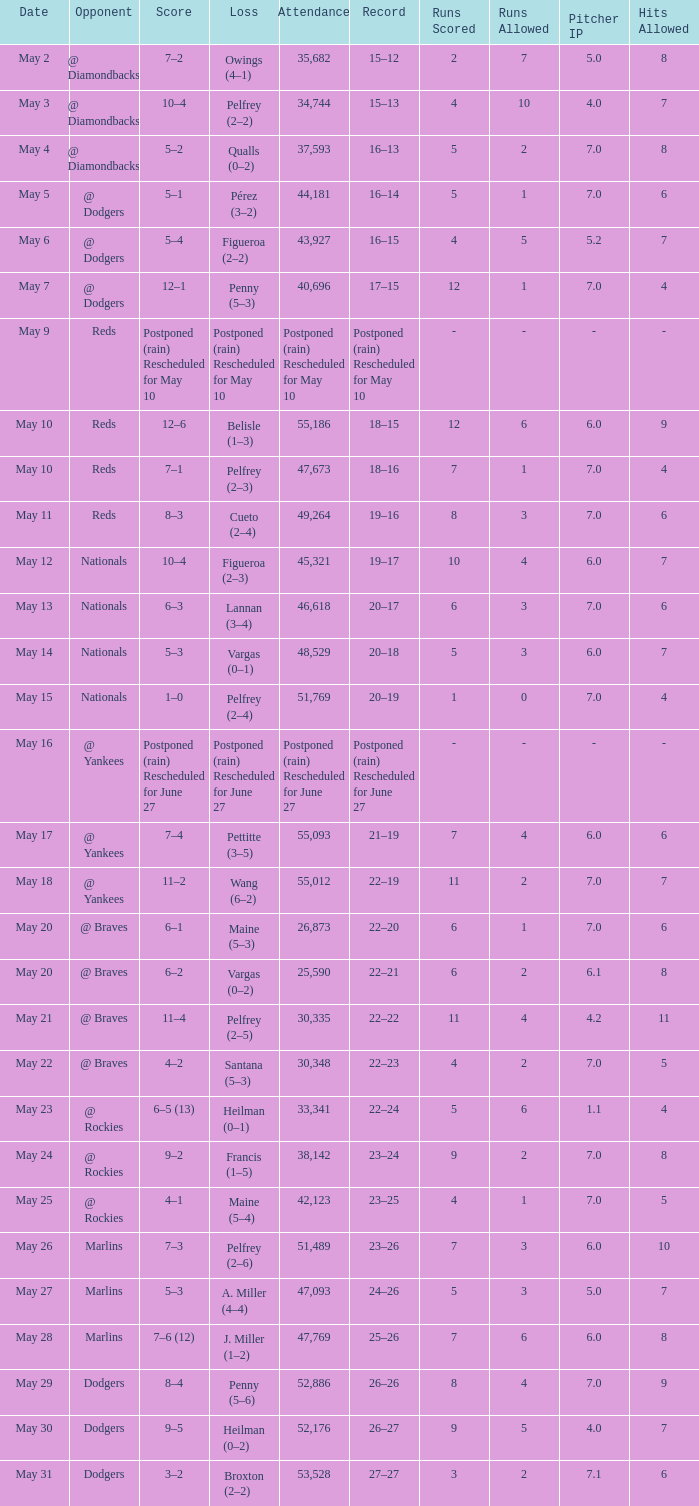Record of 22–20 involved what score? 6–1. 